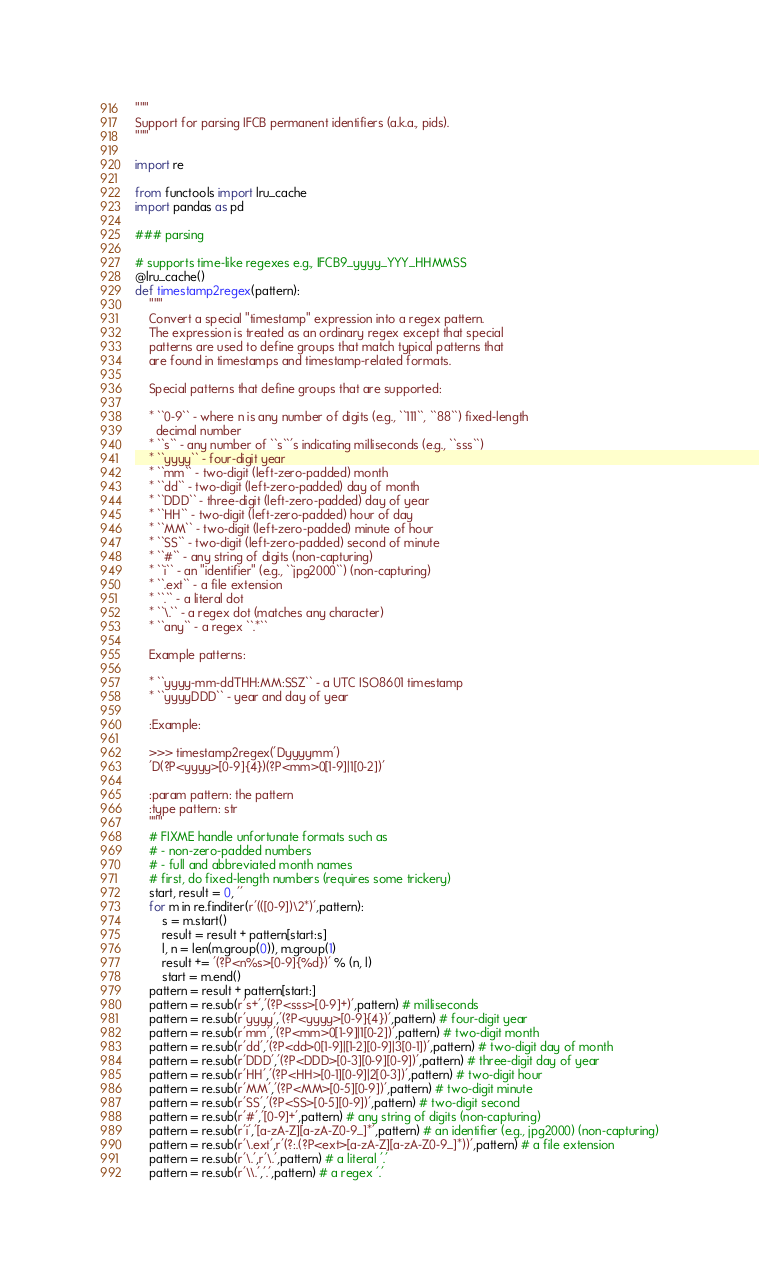Convert code to text. <code><loc_0><loc_0><loc_500><loc_500><_Python_>"""
Support for parsing IFCB permanent identifiers (a.k.a., pids).
"""

import re

from functools import lru_cache
import pandas as pd

### parsing

# supports time-like regexes e.g., IFCB9_yyyy_YYY_HHMMSS
@lru_cache()
def timestamp2regex(pattern):
    """
    Convert a special "timestamp" expression into a regex pattern.
    The expression is treated as an ordinary regex except that special
    patterns are used to define groups that match typical patterns that
    are found in timestamps and timestamp-related formats.

    Special patterns that define groups that are supported:

    * ``0-9`` - where n is any number of digits (e.g., ``111``, ``88``) fixed-length
      decimal number
    * ``s`` - any number of ``s``'s indicating milliseconds (e.g., ``sss``)
    * ``yyyy`` - four-digit year
    * ``mm`` - two-digit (left-zero-padded) month
    * ``dd`` - two-digit (left-zero-padded) day of month
    * ``DDD`` - three-digit (left-zero-padded) day of year
    * ``HH`` - two-digit (left-zero-padded) hour of day
    * ``MM`` - two-digit (left-zero-padded) minute of hour
    * ``SS`` - two-digit (left-zero-padded) second of minute
    * ``#`` - any string of digits (non-capturing)
    * ``i`` - an "identifier" (e.g., ``jpg2000``) (non-capturing)
    * ``.ext`` - a file extension
    * ``.`` - a literal dot
    * ``\.`` - a regex dot (matches any character)
    * ``any`` - a regex ``.*``

    Example patterns:

    * ``yyyy-mm-ddTHH:MM:SSZ`` - a UTC ISO8601 timestamp
    * ``yyyyDDD`` - year and day of year

    :Example:

    >>> timestamp2regex('Dyyyymm')
    'D(?P<yyyy>[0-9]{4})(?P<mm>0[1-9]|1[0-2])'

    :param pattern: the pattern
    :type pattern: str
    """
    # FIXME handle unfortunate formats such as
    # - non-zero-padded numbers
    # - full and abbreviated month names
    # first, do fixed-length numbers (requires some trickery)
    start, result = 0, ''
    for m in re.finditer(r'(([0-9])\2*)',pattern):
        s = m.start()
        result = result + pattern[start:s]
        l, n = len(m.group(0)), m.group(1)
        result += '(?P<n%s>[0-9]{%d})' % (n, l)
        start = m.end()
    pattern = result + pattern[start:]
    pattern = re.sub(r's+','(?P<sss>[0-9]+)',pattern) # milliseconds
    pattern = re.sub(r'yyyy','(?P<yyyy>[0-9]{4})',pattern) # four-digit year
    pattern = re.sub(r'mm','(?P<mm>0[1-9]|1[0-2])',pattern) # two-digit month
    pattern = re.sub(r'dd','(?P<dd>0[1-9]|[1-2][0-9]|3[0-1])',pattern) # two-digit day of month
    pattern = re.sub(r'DDD','(?P<DDD>[0-3][0-9][0-9])',pattern) # three-digit day of year
    pattern = re.sub(r'HH','(?P<HH>[0-1][0-9]|2[0-3])',pattern) # two-digit hour
    pattern = re.sub(r'MM','(?P<MM>[0-5][0-9])',pattern) # two-digit minute
    pattern = re.sub(r'SS','(?P<SS>[0-5][0-9])',pattern) # two-digit second
    pattern = re.sub(r'#','[0-9]+',pattern) # any string of digits (non-capturing)
    pattern = re.sub(r'i','[a-zA-Z][a-zA-Z0-9_]*',pattern) # an identifier (e.g., jpg2000) (non-capturing)
    pattern = re.sub(r'\.ext',r'(?:.(?P<ext>[a-zA-Z][a-zA-Z0-9_]*))',pattern) # a file extension
    pattern = re.sub(r'\.',r'\.',pattern) # a literal '.'
    pattern = re.sub(r'\\.','.',pattern) # a regex '.'</code> 